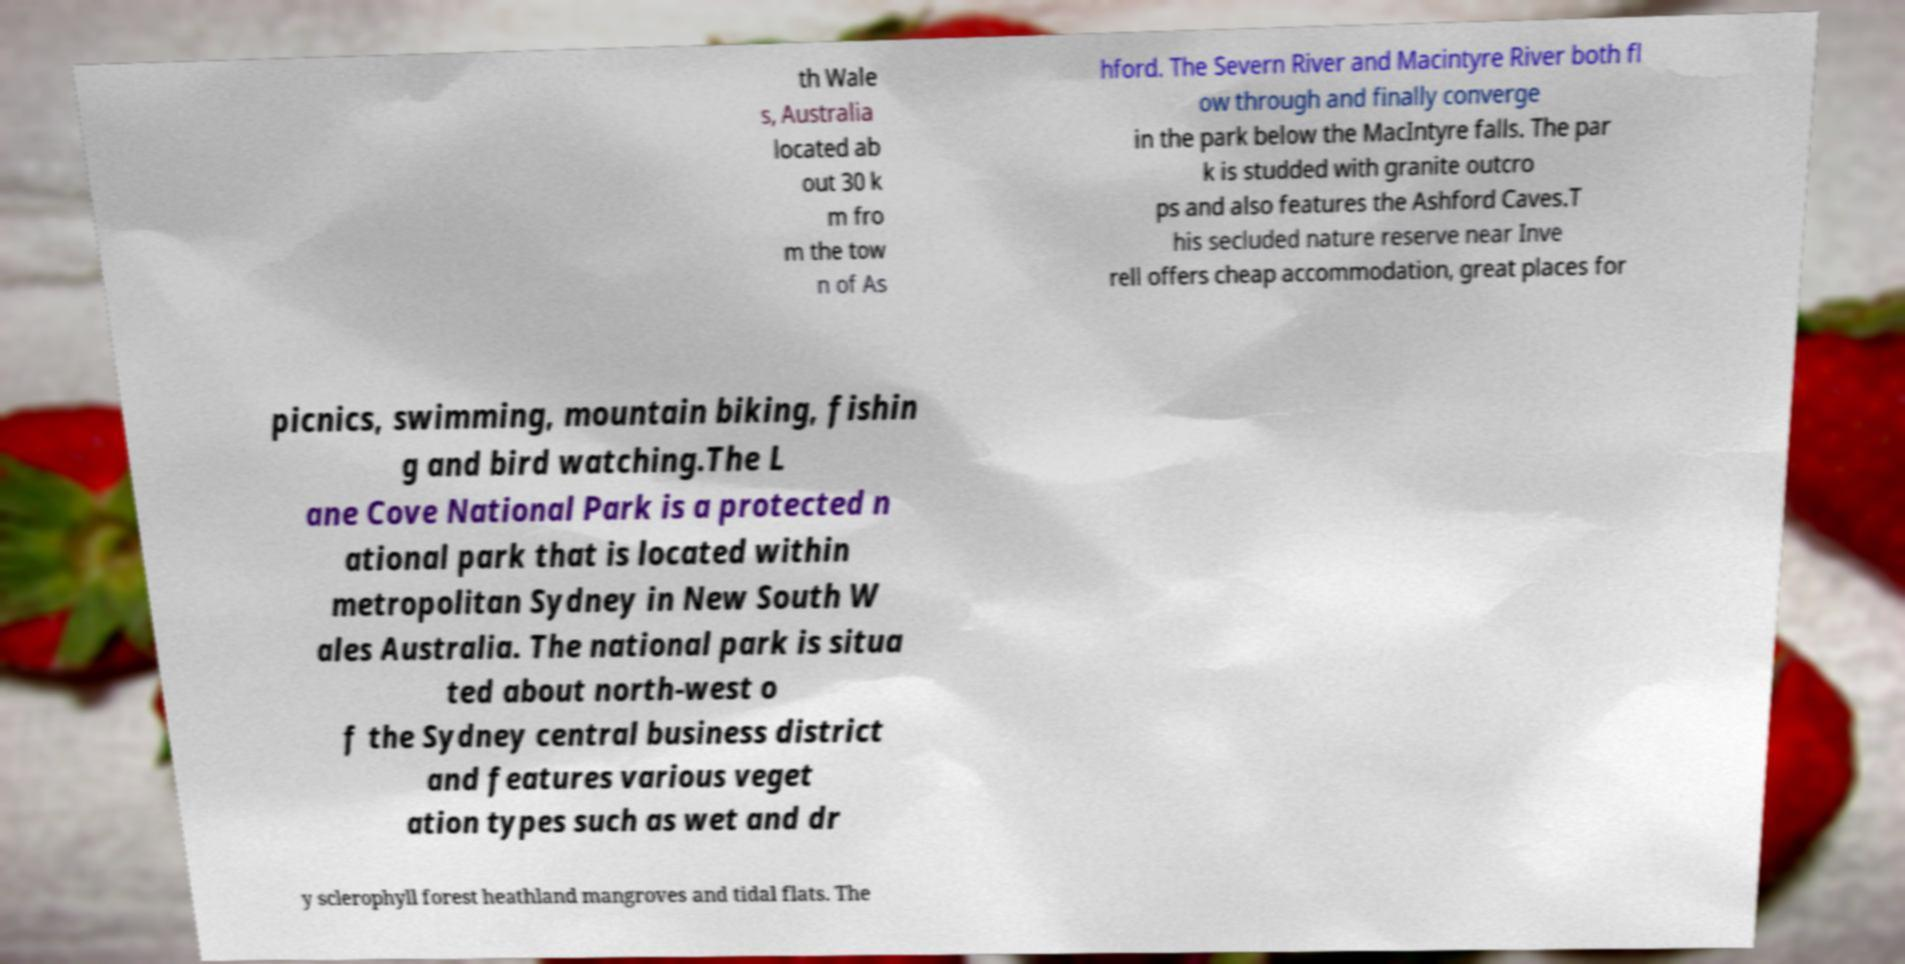Could you extract and type out the text from this image? th Wale s, Australia located ab out 30 k m fro m the tow n of As hford. The Severn River and Macintyre River both fl ow through and finally converge in the park below the MacIntyre falls. The par k is studded with granite outcro ps and also features the Ashford Caves.T his secluded nature reserve near Inve rell offers cheap accommodation, great places for picnics, swimming, mountain biking, fishin g and bird watching.The L ane Cove National Park is a protected n ational park that is located within metropolitan Sydney in New South W ales Australia. The national park is situa ted about north-west o f the Sydney central business district and features various veget ation types such as wet and dr y sclerophyll forest heathland mangroves and tidal flats. The 